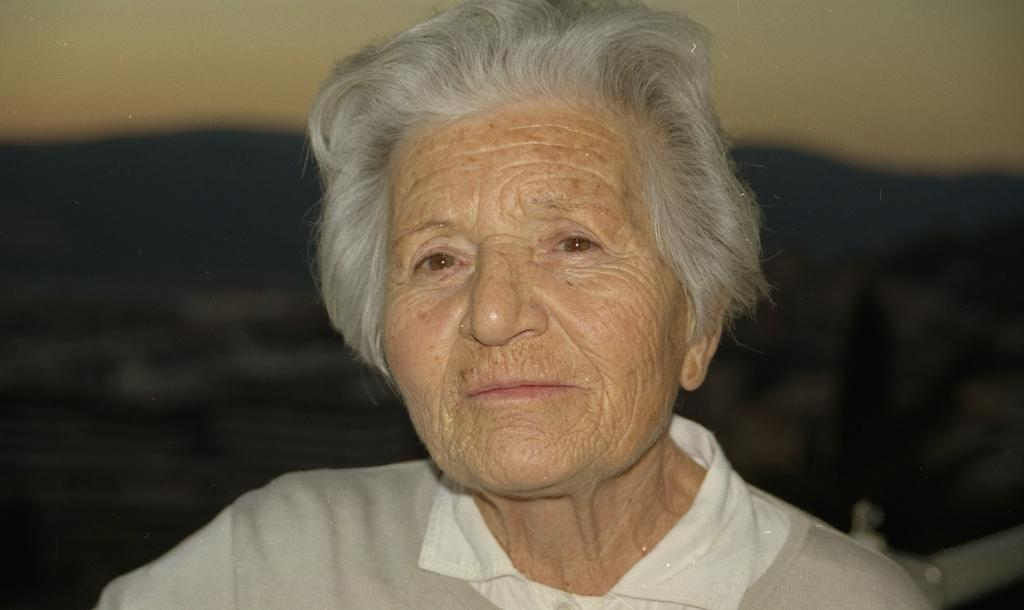Who or what is present in the image? There is a person in the image. What can be seen in the distance behind the person? There are buildings, trees, mountains, and the sky visible in the background of the image. What time of day is it in the image, and is there a cemetery nearby? The time of day cannot be determined from the image, and there is no cemetery visible in the image. 